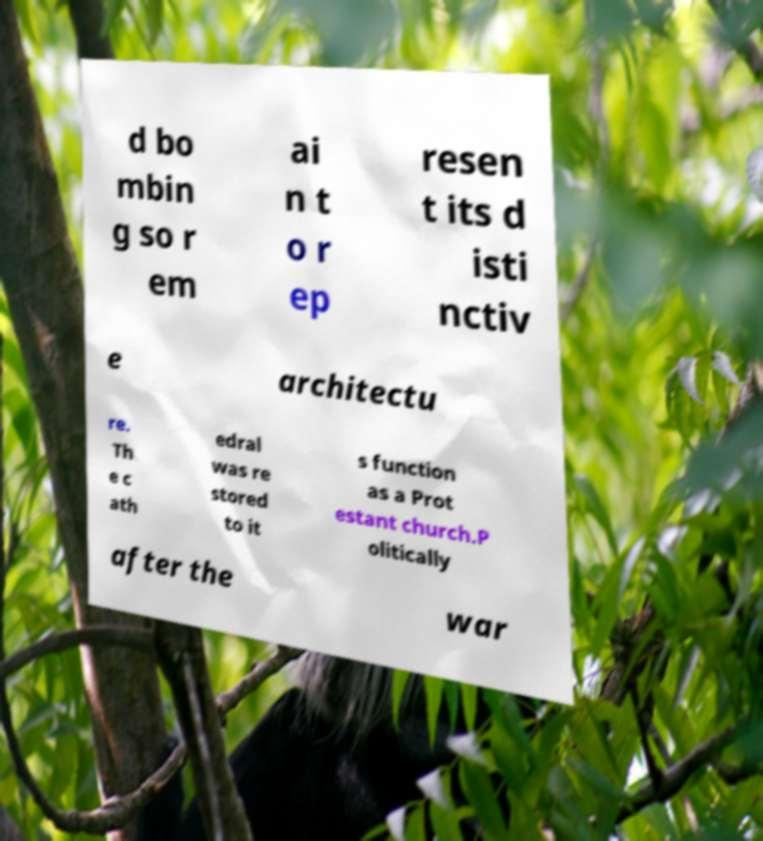Could you assist in decoding the text presented in this image and type it out clearly? d bo mbin g so r em ai n t o r ep resen t its d isti nctiv e architectu re. Th e c ath edral was re stored to it s function as a Prot estant church.P olitically after the war 